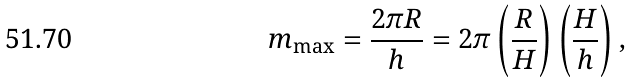<formula> <loc_0><loc_0><loc_500><loc_500>m _ { \max } = \frac { 2 \pi R } { h } = 2 \pi \left ( \frac { R } { H } \right ) \left ( \frac { H } { h } \right ) ,</formula> 